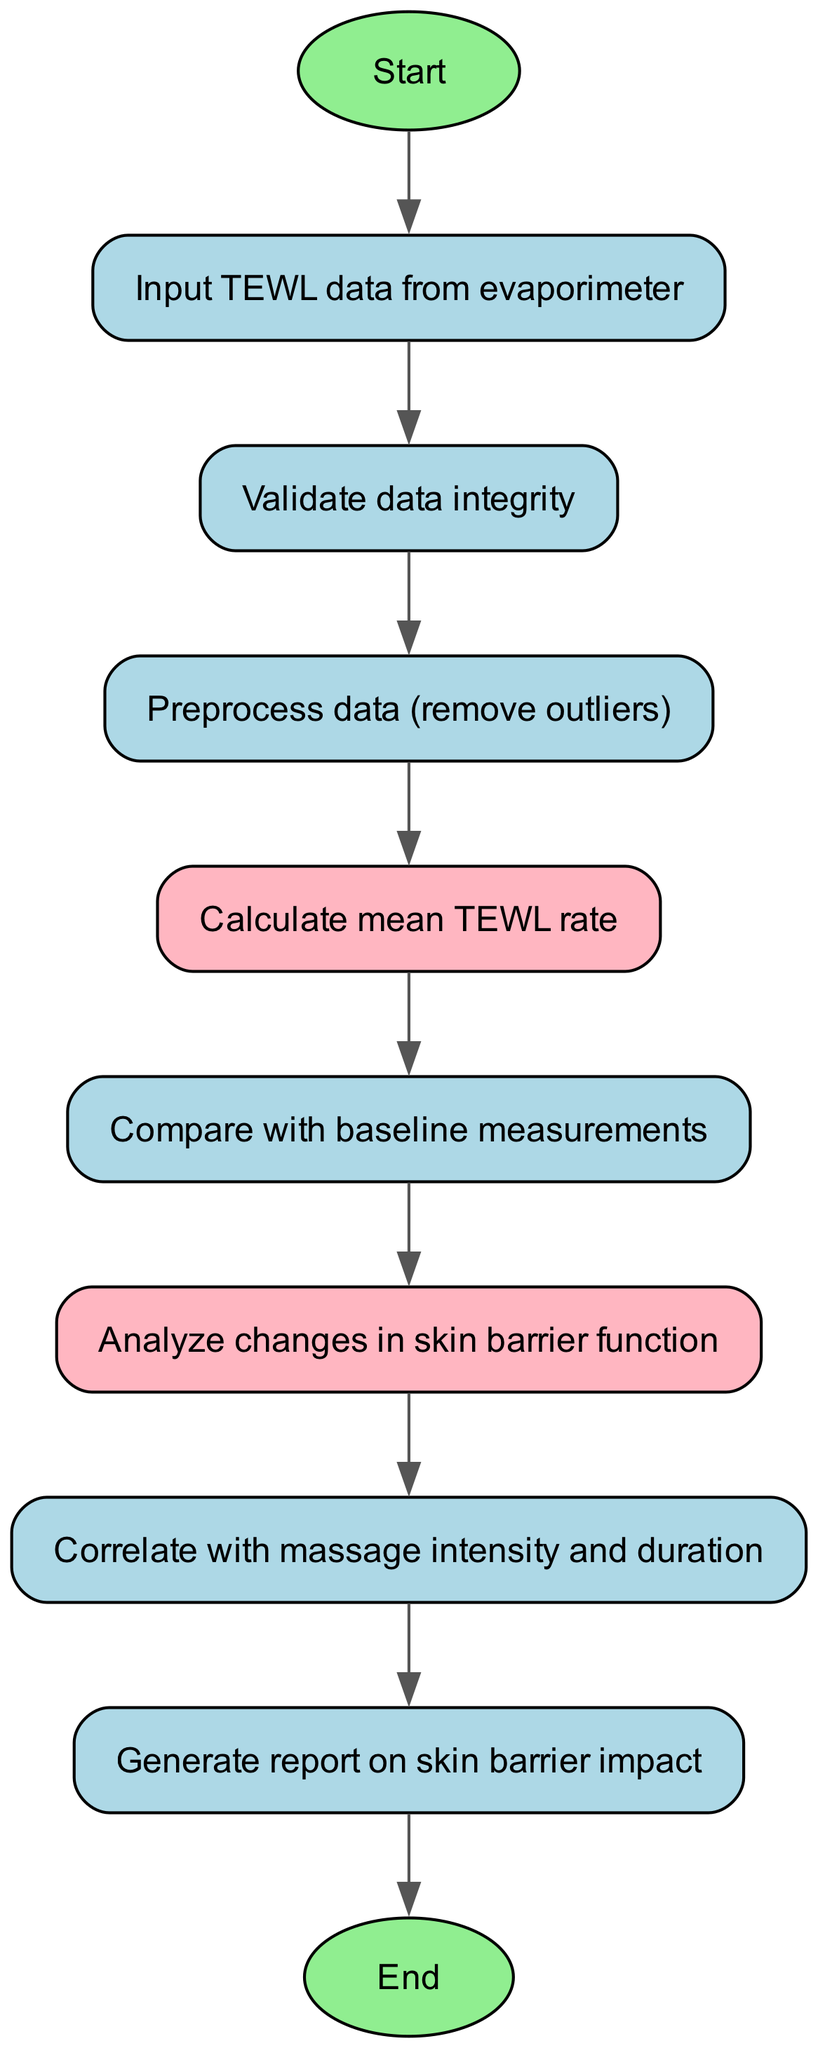What is the first step in the algorithm? The first step in the algorithm is represented by the 'start' node, which indicates the beginning of the process. From the 'start' node, the next step is to input the TEWL data.
Answer: Start How many nodes are in the flowchart? By counting the elements listed in the data, there are ten nodes, including both the 'start' and 'end' nodes.
Answer: Ten What is the last action taken before the process ends? The last action before the process ends is 'Generate report on skin barrier impact,' represented by the 'report' node. This node is connected to the 'end' node, indicating it precedes the conclusion of the flow.
Answer: Generate report on skin barrier impact What follows data validation in the flowchart? After the 'Validate data integrity' node, the next step is 'Preprocess data (remove outliers),' which indicates that the data validation process leads directly to preprocessing.
Answer: Preprocess data (remove outliers) How many flows connect the nodes in this diagram? There are nine flows connecting the nodes, as indicated by the edges in the flowchart that direct from one step to the next.
Answer: Nine Which step analyzes changes in skin barrier function? The 'Analyze changes in skin barrier function' node is the step that focuses on this analysis, following the comparison of TEWL measurements with baseline data.
Answer: Analyze changes in skin barrier function What is the relationship between 'Calculate mean TEWL rate' and 'Compare with baseline measurements'? The relationship is that the 'Calculate mean TEWL rate' step directly leads to the 'Compare with baseline measurements' step, indicating that the calculation occurs before comparison.
Answer: Sequence relation Which node is colored differently and what does it represent? The nodes 'Calculate mean TEWL rate' and 'Analyze changes in skin barrier function' are colored in pink, indicating they are key analytical steps in the process.
Answer: Calculate mean TEWL rate, Analyze changes in skin barrier function 